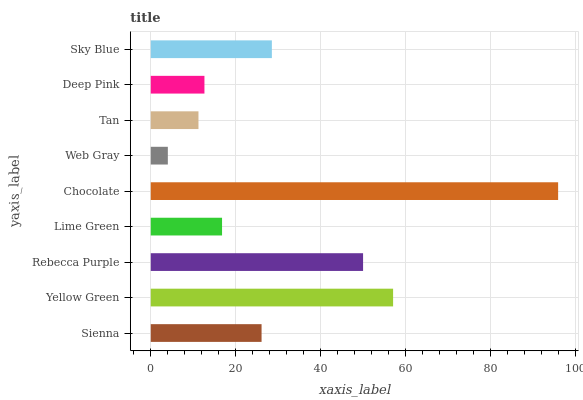Is Web Gray the minimum?
Answer yes or no. Yes. Is Chocolate the maximum?
Answer yes or no. Yes. Is Yellow Green the minimum?
Answer yes or no. No. Is Yellow Green the maximum?
Answer yes or no. No. Is Yellow Green greater than Sienna?
Answer yes or no. Yes. Is Sienna less than Yellow Green?
Answer yes or no. Yes. Is Sienna greater than Yellow Green?
Answer yes or no. No. Is Yellow Green less than Sienna?
Answer yes or no. No. Is Sienna the high median?
Answer yes or no. Yes. Is Sienna the low median?
Answer yes or no. Yes. Is Chocolate the high median?
Answer yes or no. No. Is Lime Green the low median?
Answer yes or no. No. 